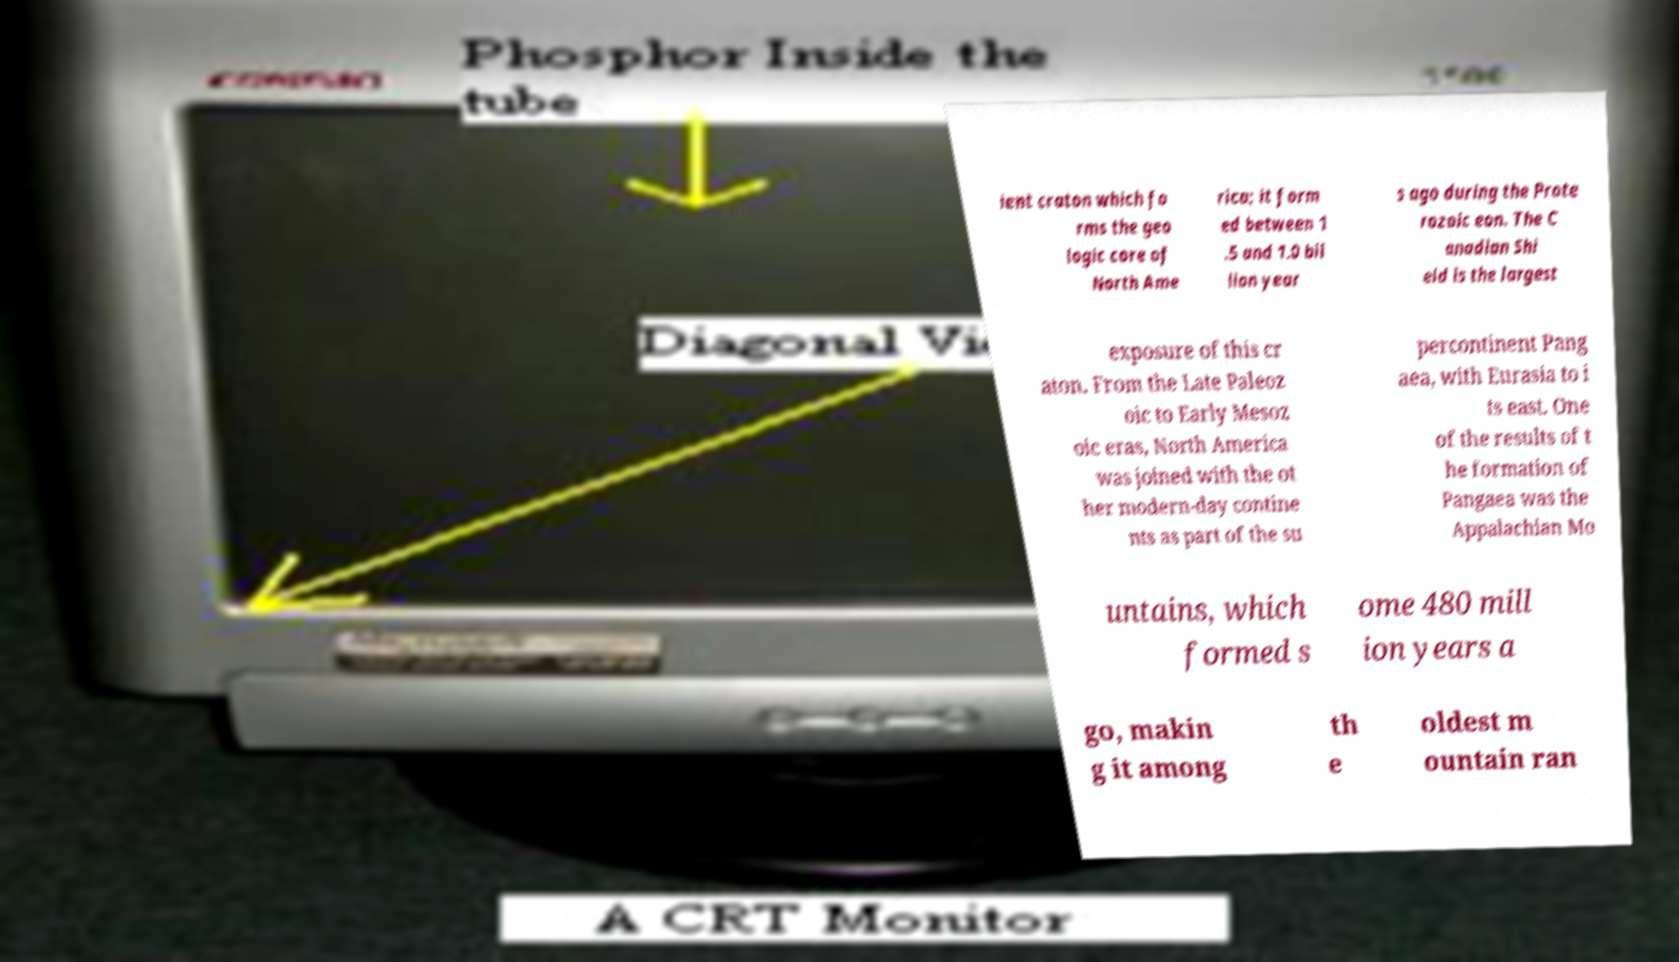Please read and relay the text visible in this image. What does it say? ient craton which fo rms the geo logic core of North Ame rica; it form ed between 1 .5 and 1.0 bil lion year s ago during the Prote rozoic eon. The C anadian Shi eld is the largest exposure of this cr aton. From the Late Paleoz oic to Early Mesoz oic eras, North America was joined with the ot her modern-day contine nts as part of the su percontinent Pang aea, with Eurasia to i ts east. One of the results of t he formation of Pangaea was the Appalachian Mo untains, which formed s ome 480 mill ion years a go, makin g it among th e oldest m ountain ran 